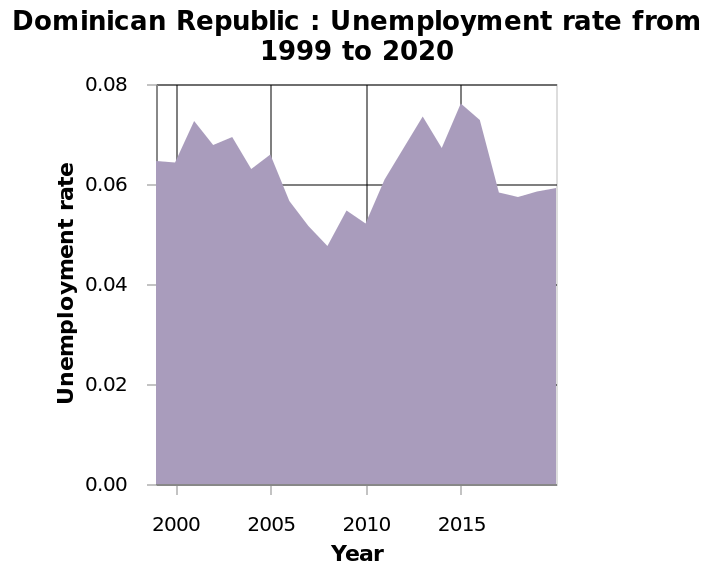<image>
What is the range of the unemployment rate on the y-axis?  The range of the unemployment rate on the y-axis is from 0.00 to 0.08. Offer a thorough analysis of the image. The lowest unemployment rate was sometime in 2006-2007 where it was around 0.045. The highest unemployment rate was sometime in 2015 where it was 0.075 after which is dropped rapidly until around 2016 where it started to level off. What was the specific value of the highest unemployment rate mentioned?  The highest unemployment rate mentioned was 0.075. When did the unemployment rate drop rapidly after reaching its peak in 2015?  The unemployment rate dropped rapidly until around 2016 after reaching its peak in 2015. 